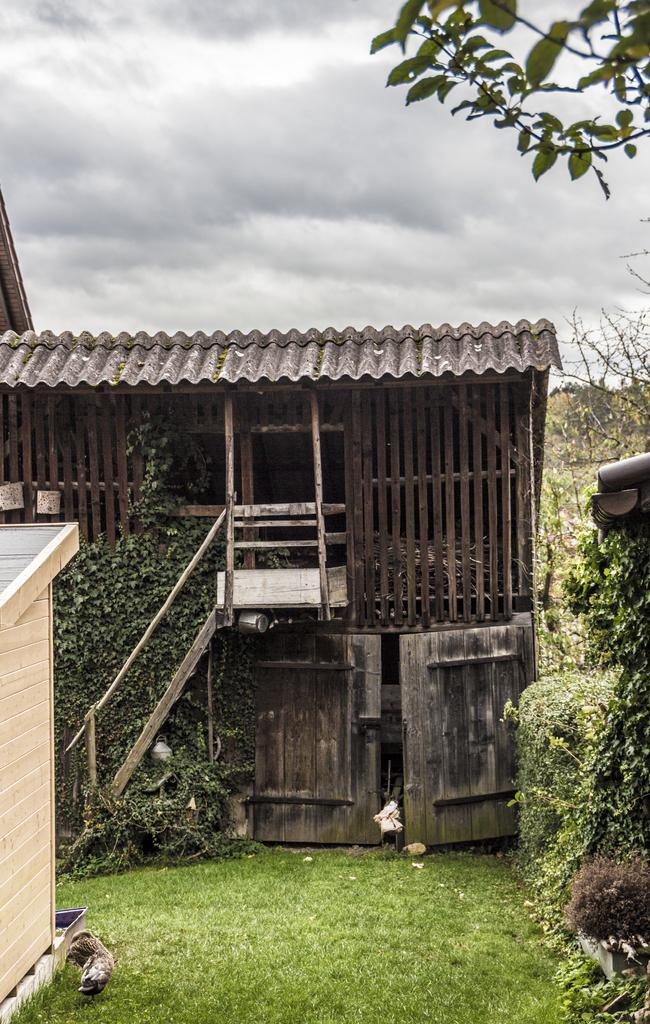What type of house is in the image? There is a wooden house in the image. What can be seen around the house? There are many trees around the house. What is in front of the house? There is grass in front of the house. What trick does the leaf perform in the image? There is no leaf present in the image, so no trick can be observed. 